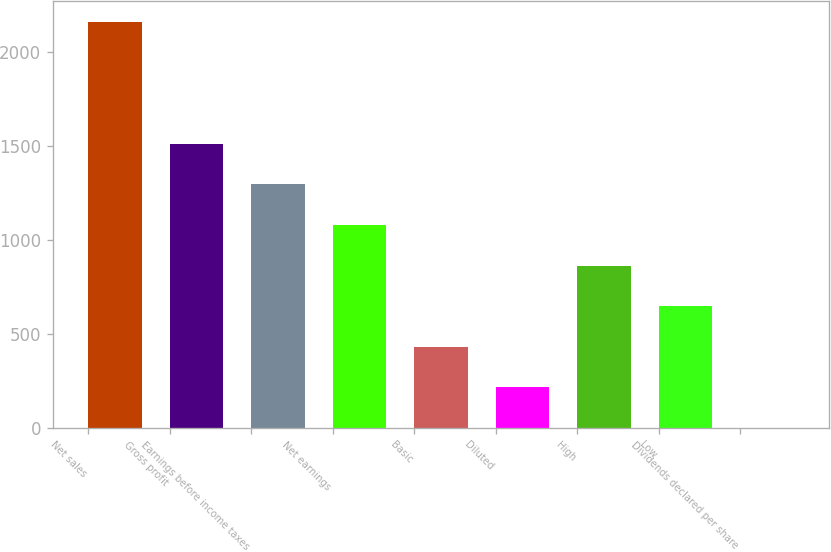<chart> <loc_0><loc_0><loc_500><loc_500><bar_chart><fcel>Net sales<fcel>Gross profit<fcel>Earnings before income taxes<fcel>Net earnings<fcel>Basic<fcel>Diluted<fcel>High<fcel>Low<fcel>Dividends declared per share<nl><fcel>2161<fcel>1512.77<fcel>1296.69<fcel>1080.61<fcel>432.37<fcel>216.29<fcel>864.53<fcel>648.45<fcel>0.21<nl></chart> 